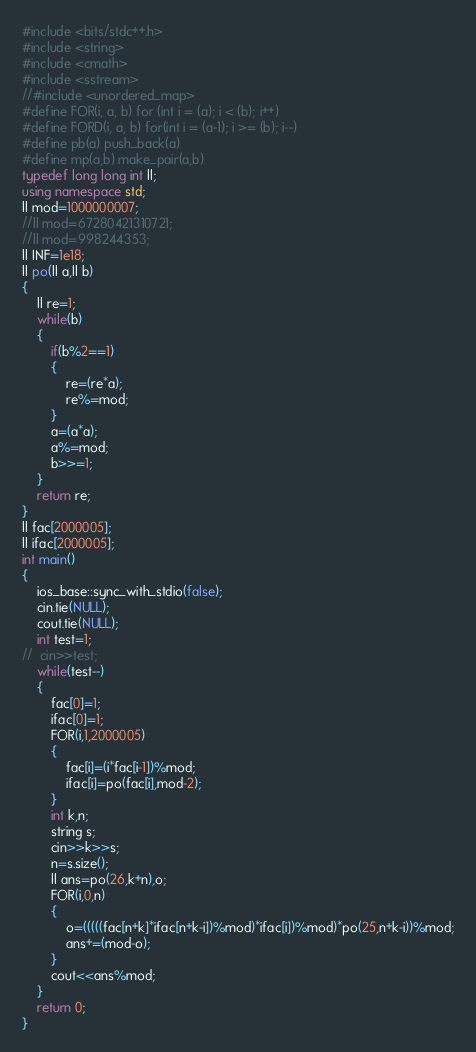<code> <loc_0><loc_0><loc_500><loc_500><_C++_>#include <bits/stdc++.h>
#include <string>
#include <cmath>
#include <sstream>
//#include <unordered_map>
#define FOR(i, a, b) for (int i = (a); i < (b); i++)
#define FORD(i, a, b) for(int i = (a-1); i >= (b); i--)
#define pb(a) push_back(a)
#define mp(a,b) make_pair(a,b)
typedef long long int ll;
using namespace std;
ll mod=1000000007;
//ll mod=67280421310721;
//ll mod=998244353;
ll INF=1e18;
ll po(ll a,ll b)
{
	ll re=1;
	while(b)
	{
		if(b%2==1)
		{
			re=(re*a);
			re%=mod;
		}
		a=(a*a);
		a%=mod;
		b>>=1;
	}
	return re;
}
ll fac[2000005];
ll ifac[2000005];
int main()
{
	ios_base::sync_with_stdio(false);
	cin.tie(NULL);
	cout.tie(NULL);
	int test=1;
//	cin>>test;
	while(test--)
	{
		fac[0]=1;
		ifac[0]=1;
		FOR(i,1,2000005)
		{
			fac[i]=(i*fac[i-1])%mod;
			ifac[i]=po(fac[i],mod-2);
		}
		int k,n;
		string s;
		cin>>k>>s;
		n=s.size();
		ll ans=po(26,k+n),o;
		FOR(i,0,n)
		{
			o=(((((fac[n+k]*ifac[n+k-i])%mod)*ifac[i])%mod)*po(25,n+k-i))%mod;
			ans+=(mod-o);
		}
		cout<<ans%mod;
	}
	return 0;
}</code> 